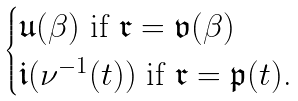<formula> <loc_0><loc_0><loc_500><loc_500>\begin{cases} \mathfrak { u } ( \beta ) \text { if $\mathfrak{r}=\mathfrak{v}(\beta)$} \\ \mathfrak { i } ( \nu ^ { - 1 } ( t ) ) \text { if $\mathfrak{r}=\mathfrak{p}(t)$.} \end{cases}</formula> 